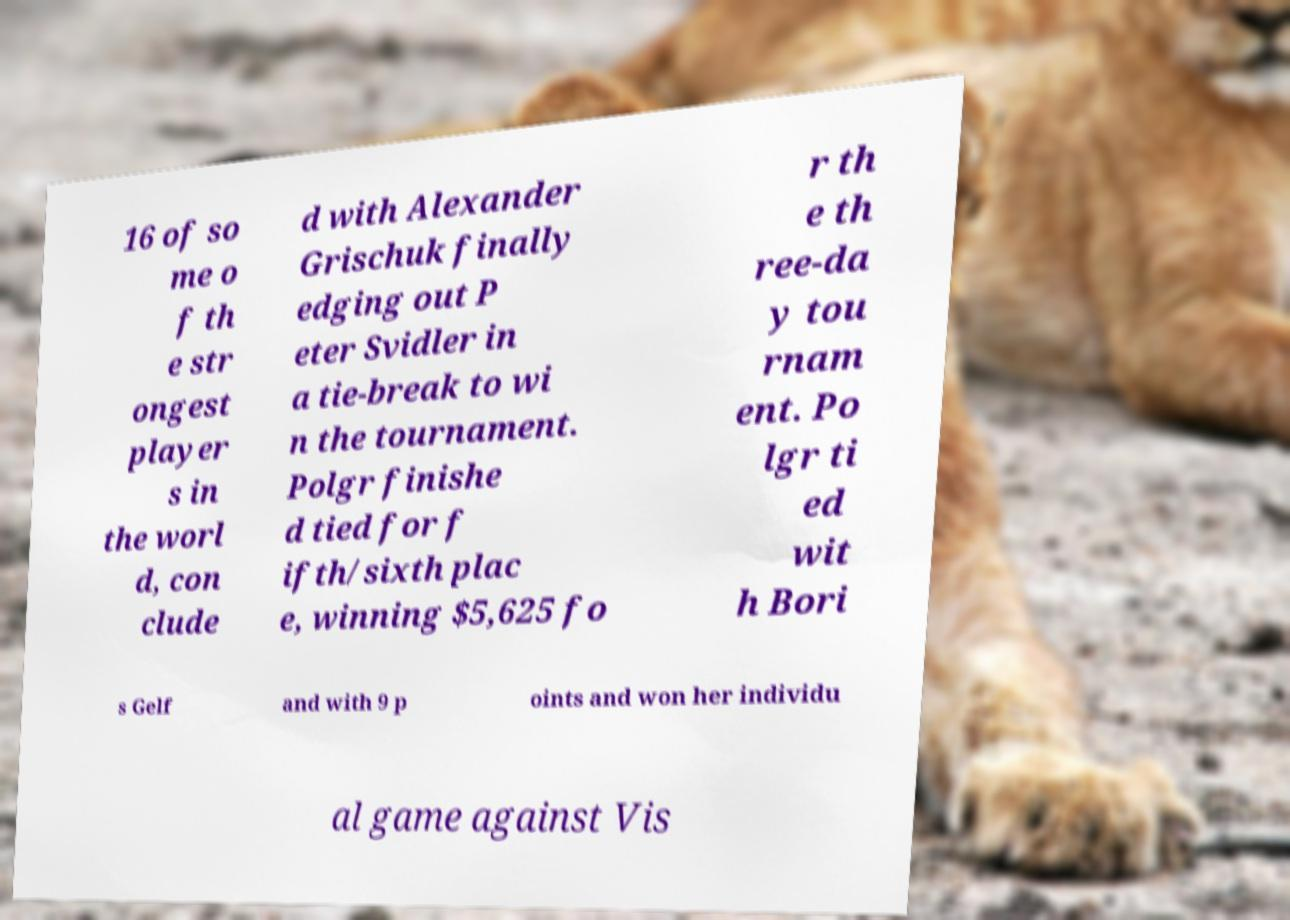What messages or text are displayed in this image? I need them in a readable, typed format. 16 of so me o f th e str ongest player s in the worl d, con clude d with Alexander Grischuk finally edging out P eter Svidler in a tie-break to wi n the tournament. Polgr finishe d tied for f ifth/sixth plac e, winning $5,625 fo r th e th ree-da y tou rnam ent. Po lgr ti ed wit h Bori s Gelf and with 9 p oints and won her individu al game against Vis 